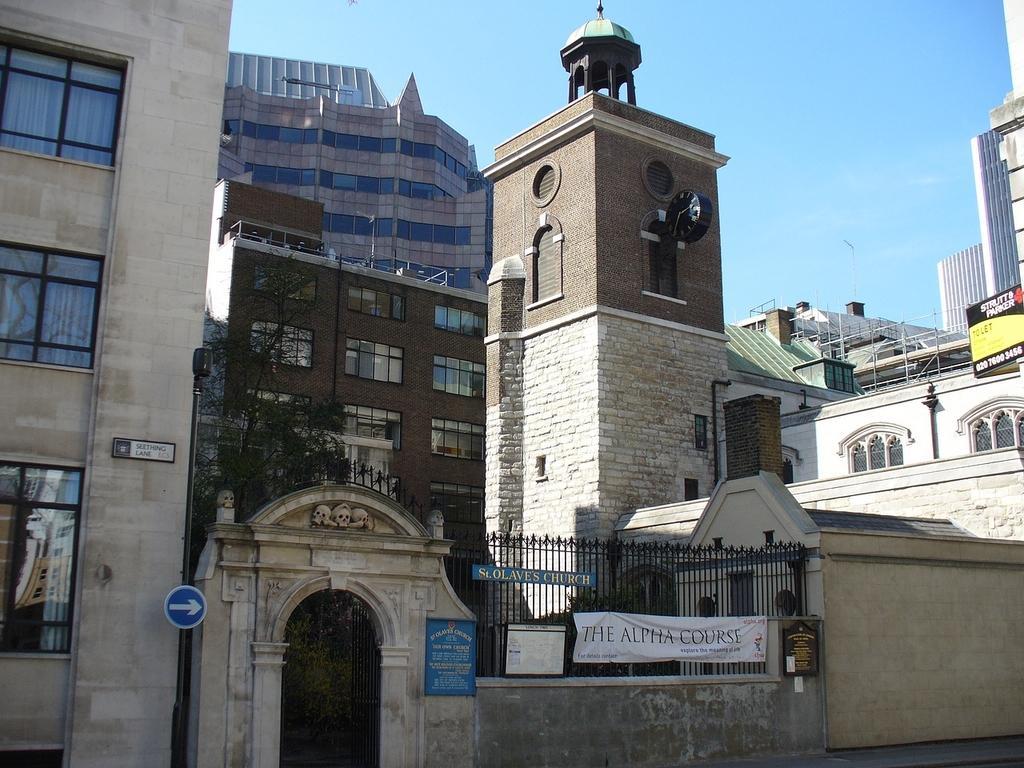Can you describe this image briefly? In the center of the image we can see a clock tower. In the background of the image we can see the buildings, trees, roofs, windows, rods. At the bottom of the image we can see the grilles, banner, boards, wall, arch, poles, sign board. At the top of the image we can see the sky. 